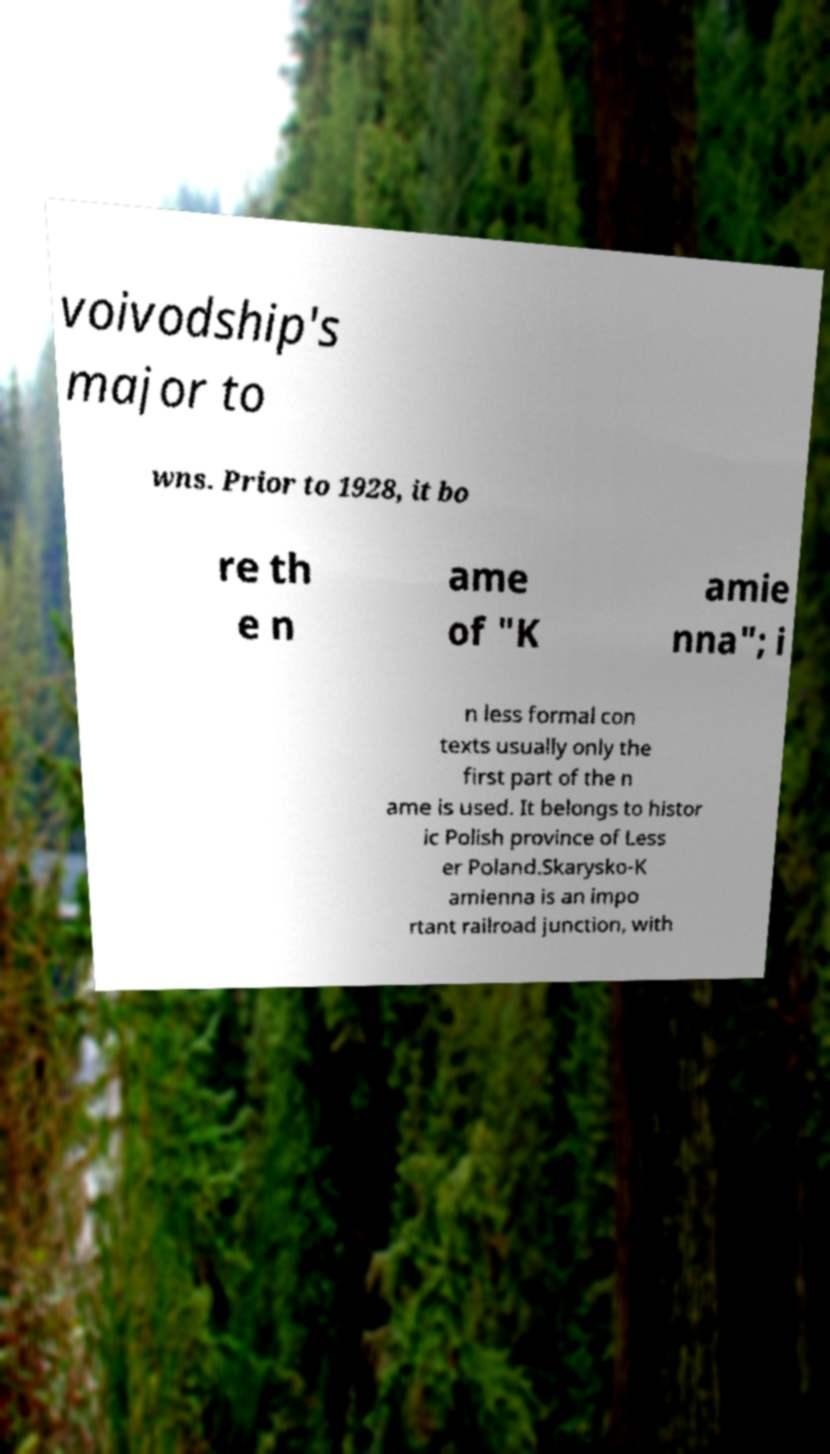What messages or text are displayed in this image? I need them in a readable, typed format. voivodship's major to wns. Prior to 1928, it bo re th e n ame of "K amie nna"; i n less formal con texts usually only the first part of the n ame is used. It belongs to histor ic Polish province of Less er Poland.Skarysko-K amienna is an impo rtant railroad junction, with 